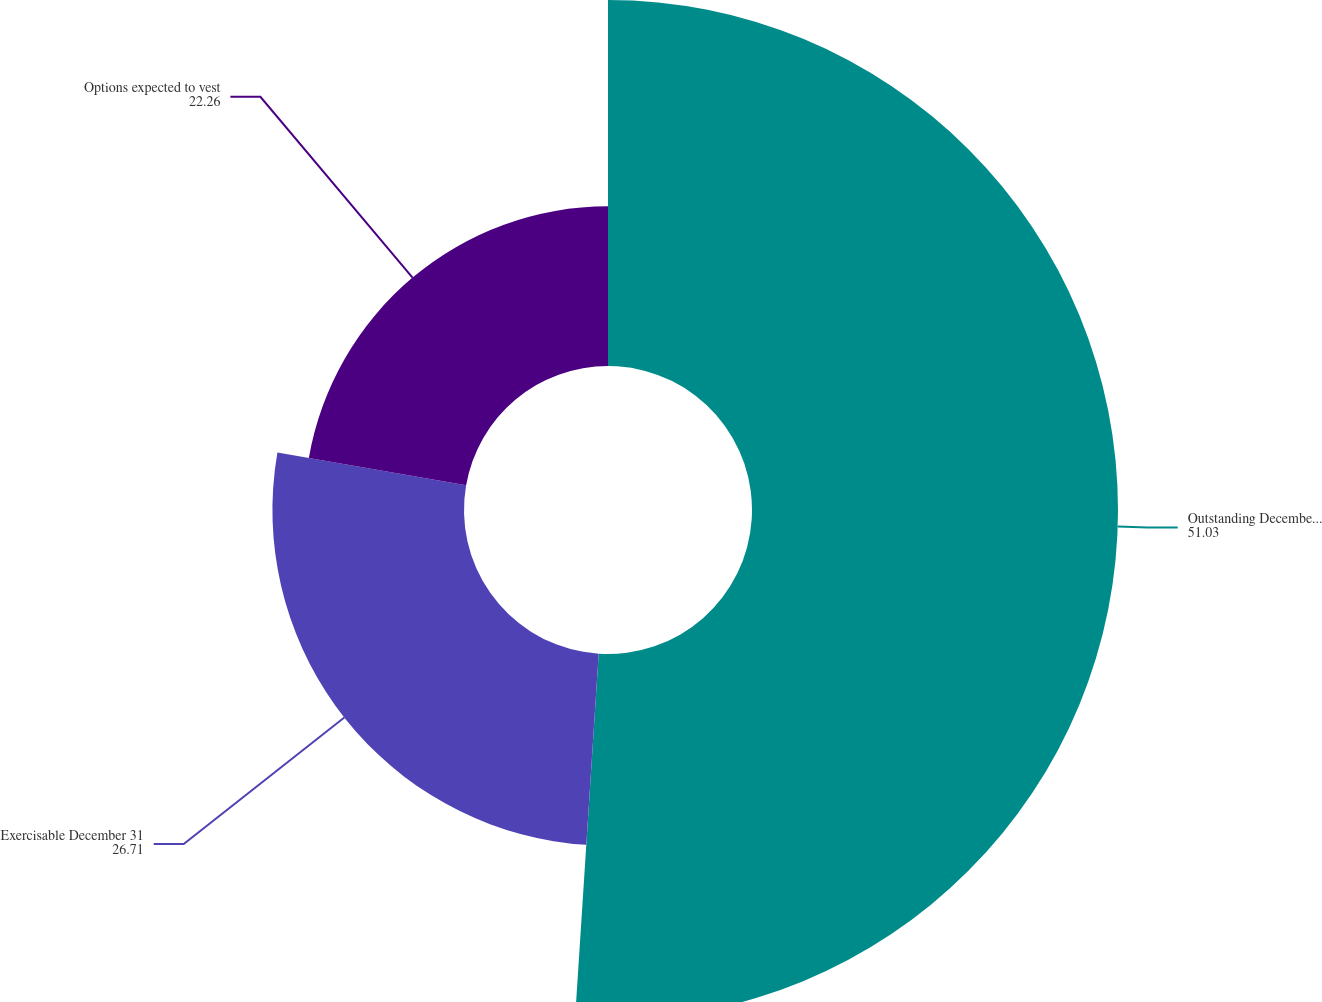<chart> <loc_0><loc_0><loc_500><loc_500><pie_chart><fcel>Outstanding December 31<fcel>Exercisable December 31<fcel>Options expected to vest<nl><fcel>51.03%<fcel>26.71%<fcel>22.26%<nl></chart> 